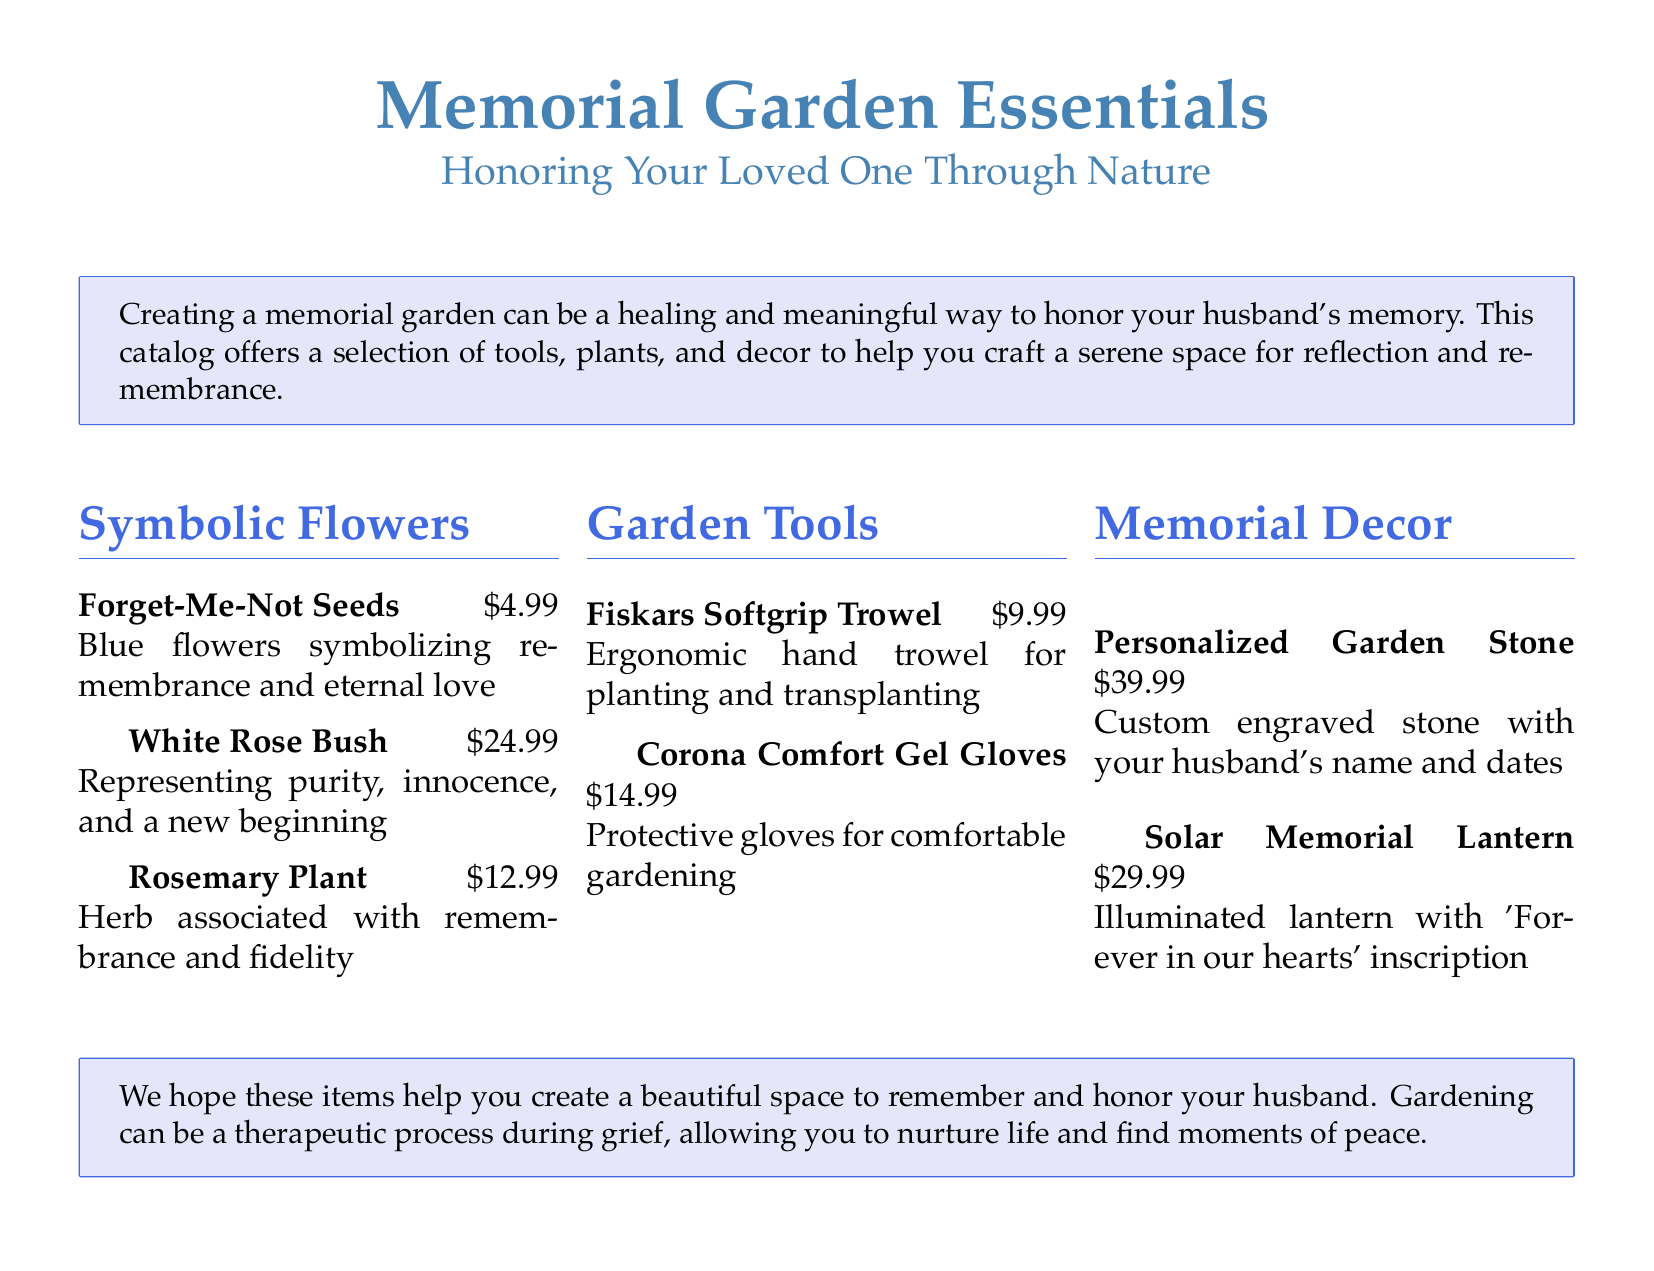What is the title of the catalog? The title is prominently displayed at the top of the document and is a key feature of the catalog.
Answer: Memorial Garden Essentials What is the price of the Forget-Me-Not seeds? The price is listed next to the product in the catalog's section on symbolic flowers.
Answer: $4.99 Which flower represents purity and innocence? This flower's significance is highlighted in the description provided in the catalog.
Answer: White Rose Bush What decor item features an inscription? This item is described in the memorial decor section and includes a specific quote.
Answer: Solar Memorial Lantern How much do the Corona Comfort Gel Gloves cost? The price for this gardening tool is included in the document.
Answer: $14.99 What does rosemary symbolize? This is mentioned in the description of the rosemary plant under the symbolic flowers section.
Answer: Remembrance and fidelity What type of garden item can be personalized? This item allows for customization and is located in the memorial decor section of the catalog.
Answer: Personalized Garden Stone How many items are listed under the Garden Tools section? The number of items in this section provides insight into the variety offered in the catalog.
Answer: Two items What theme does the catalog emphasize for the memorial garden? The overall focus and emotional theme are captured in the introductory text.
Answer: Healing and remembrance 